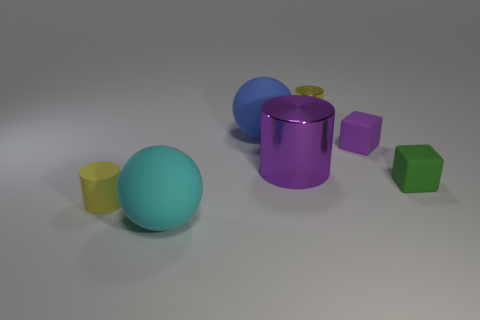Subtract all yellow shiny cylinders. How many cylinders are left? 2 Add 3 small cyan matte spheres. How many objects exist? 10 Subtract 1 spheres. How many spheres are left? 1 Subtract all tiny purple spheres. Subtract all tiny yellow objects. How many objects are left? 5 Add 2 tiny things. How many tiny things are left? 6 Add 6 yellow cylinders. How many yellow cylinders exist? 8 Subtract all purple blocks. How many blocks are left? 1 Subtract 0 cyan blocks. How many objects are left? 7 Subtract all spheres. How many objects are left? 5 Subtract all brown cubes. Subtract all gray spheres. How many cubes are left? 2 